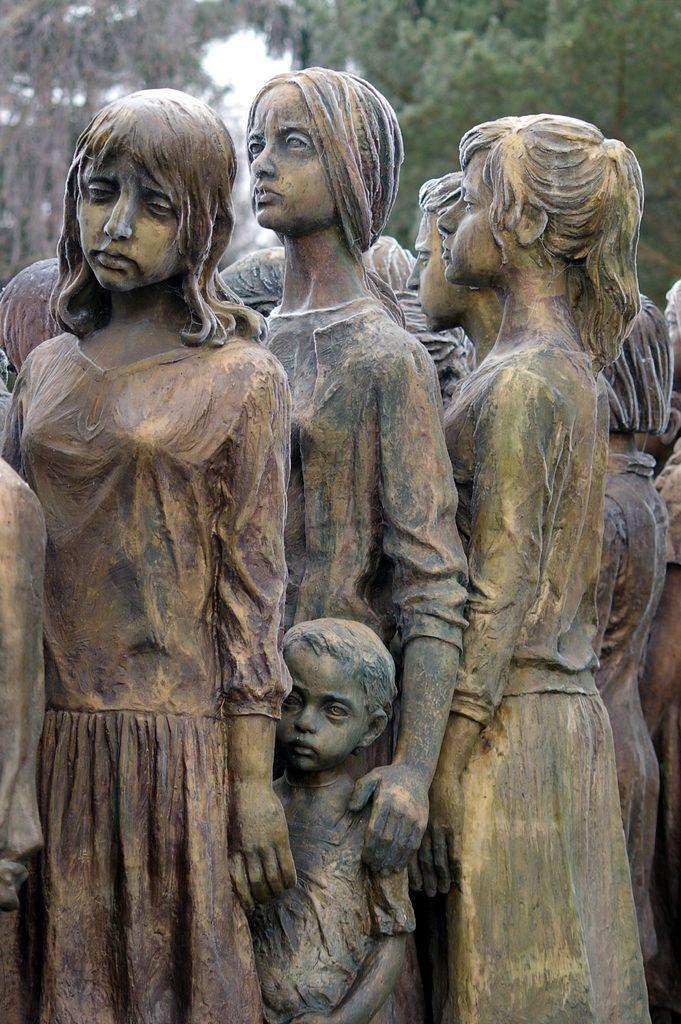Could you give a brief overview of what you see in this image? In this picture we can see statues of people and in the background we can see trees and the sky. 